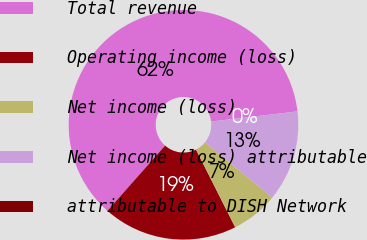Convert chart to OTSL. <chart><loc_0><loc_0><loc_500><loc_500><pie_chart><fcel>Total revenue<fcel>Operating income (loss)<fcel>Net income (loss)<fcel>Net income (loss) attributable<fcel>attributable to DISH Network<nl><fcel>61.62%<fcel>18.96%<fcel>6.63%<fcel>12.79%<fcel>0.0%<nl></chart> 